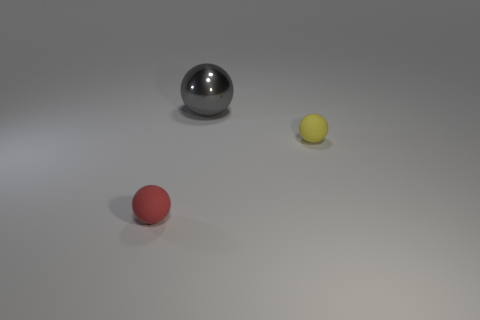Subtract all yellow spheres. Subtract all blue cylinders. How many spheres are left? 2 Add 1 red objects. How many objects exist? 4 Add 1 red matte things. How many red matte things are left? 2 Add 2 big spheres. How many big spheres exist? 3 Subtract 0 green balls. How many objects are left? 3 Subtract all tiny yellow metal cubes. Subtract all gray shiny objects. How many objects are left? 2 